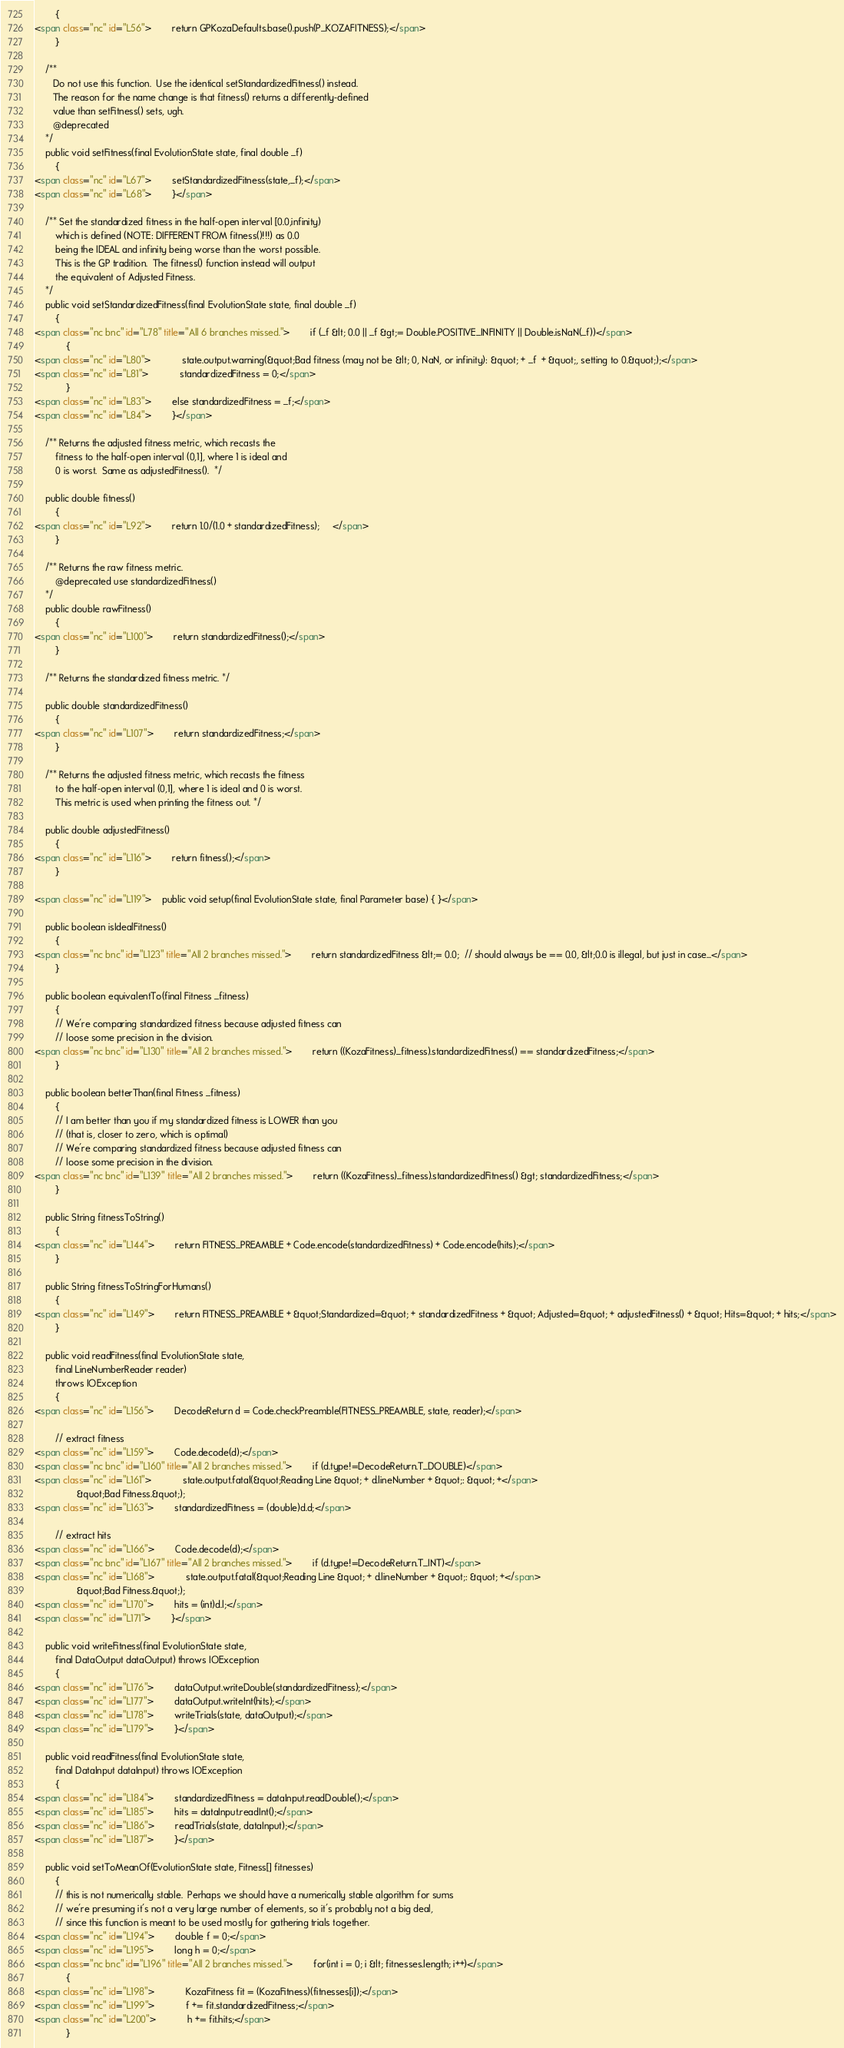<code> <loc_0><loc_0><loc_500><loc_500><_HTML_>        {
<span class="nc" id="L56">        return GPKozaDefaults.base().push(P_KOZAFITNESS);</span>
        }
        
    /**
       Do not use this function.  Use the identical setStandardizedFitness() instead.
       The reason for the name change is that fitness() returns a differently-defined
       value than setFitness() sets, ugh.
       @deprecated
    */
    public void setFitness(final EvolutionState state, final double _f)
        {
<span class="nc" id="L67">        setStandardizedFitness(state,_f);</span>
<span class="nc" id="L68">        }</span>

    /** Set the standardized fitness in the half-open interval [0.0,infinity)
        which is defined (NOTE: DIFFERENT FROM fitness()!!!) as 0.0 
        being the IDEAL and infinity being worse than the worst possible.
        This is the GP tradition.  The fitness() function instead will output
        the equivalent of Adjusted Fitness.
    */
    public void setStandardizedFitness(final EvolutionState state, final double _f)
        {
<span class="nc bnc" id="L78" title="All 6 branches missed.">        if (_f &lt; 0.0 || _f &gt;= Double.POSITIVE_INFINITY || Double.isNaN(_f))</span>
            {
<span class="nc" id="L80">            state.output.warning(&quot;Bad fitness (may not be &lt; 0, NaN, or infinity): &quot; + _f  + &quot;, setting to 0.&quot;);</span>
<span class="nc" id="L81">            standardizedFitness = 0;</span>
            }
<span class="nc" id="L83">        else standardizedFitness = _f;</span>
<span class="nc" id="L84">        }</span>

    /** Returns the adjusted fitness metric, which recasts the
        fitness to the half-open interval (0,1], where 1 is ideal and
        0 is worst.  Same as adjustedFitness().  */

    public double fitness()
        {
<span class="nc" id="L92">        return 1.0/(1.0 + standardizedFitness);     </span>
        }

    /** Returns the raw fitness metric.  
        @deprecated use standardizedFitness()
    */
    public double rawFitness()
        {
<span class="nc" id="L100">        return standardizedFitness();</span>
        }

    /** Returns the standardized fitness metric. */

    public double standardizedFitness()
        {
<span class="nc" id="L107">        return standardizedFitness;</span>
        }

    /** Returns the adjusted fitness metric, which recasts the fitness
        to the half-open interval (0,1], where 1 is ideal and 0 is worst.
        This metric is used when printing the fitness out. */

    public double adjustedFitness()
        {
<span class="nc" id="L116">        return fitness();</span>
        }

<span class="nc" id="L119">    public void setup(final EvolutionState state, final Parameter base) { }</span>
    
    public boolean isIdealFitness()
        {
<span class="nc bnc" id="L123" title="All 2 branches missed.">        return standardizedFitness &lt;= 0.0;  // should always be == 0.0, &lt;0.0 is illegal, but just in case...</span>
        }
    
    public boolean equivalentTo(final Fitness _fitness)
        {
        // We're comparing standardized fitness because adjusted fitness can
        // loose some precision in the division.
<span class="nc bnc" id="L130" title="All 2 branches missed.">        return ((KozaFitness)_fitness).standardizedFitness() == standardizedFitness;</span>
        }

    public boolean betterThan(final Fitness _fitness)
        {
        // I am better than you if my standardized fitness is LOWER than you
        // (that is, closer to zero, which is optimal)
        // We're comparing standardized fitness because adjusted fitness can
        // loose some precision in the division.
<span class="nc bnc" id="L139" title="All 2 branches missed.">        return ((KozaFitness)_fitness).standardizedFitness() &gt; standardizedFitness;</span>
        }
 
    public String fitnessToString()
        {
<span class="nc" id="L144">        return FITNESS_PREAMBLE + Code.encode(standardizedFitness) + Code.encode(hits);</span>
        }
        
    public String fitnessToStringForHumans()
        {
<span class="nc" id="L149">        return FITNESS_PREAMBLE + &quot;Standardized=&quot; + standardizedFitness + &quot; Adjusted=&quot; + adjustedFitness() + &quot; Hits=&quot; + hits;</span>
        }
            
    public void readFitness(final EvolutionState state, 
        final LineNumberReader reader)
        throws IOException
        {
<span class="nc" id="L156">        DecodeReturn d = Code.checkPreamble(FITNESS_PREAMBLE, state, reader);</span>
        
        // extract fitness
<span class="nc" id="L159">        Code.decode(d);</span>
<span class="nc bnc" id="L160" title="All 2 branches missed.">        if (d.type!=DecodeReturn.T_DOUBLE)</span>
<span class="nc" id="L161">            state.output.fatal(&quot;Reading Line &quot; + d.lineNumber + &quot;: &quot; +</span>
                &quot;Bad Fitness.&quot;);
<span class="nc" id="L163">        standardizedFitness = (double)d.d;</span>
        
        // extract hits
<span class="nc" id="L166">        Code.decode(d);</span>
<span class="nc bnc" id="L167" title="All 2 branches missed.">        if (d.type!=DecodeReturn.T_INT)</span>
<span class="nc" id="L168">            state.output.fatal(&quot;Reading Line &quot; + d.lineNumber + &quot;: &quot; +</span>
                &quot;Bad Fitness.&quot;);
<span class="nc" id="L170">        hits = (int)d.l;</span>
<span class="nc" id="L171">        }</span>

    public void writeFitness(final EvolutionState state,
        final DataOutput dataOutput) throws IOException
        {
<span class="nc" id="L176">        dataOutput.writeDouble(standardizedFitness);</span>
<span class="nc" id="L177">        dataOutput.writeInt(hits);</span>
<span class="nc" id="L178">        writeTrials(state, dataOutput);</span>
<span class="nc" id="L179">        }</span>

    public void readFitness(final EvolutionState state,
        final DataInput dataInput) throws IOException
        {
<span class="nc" id="L184">        standardizedFitness = dataInput.readDouble();</span>
<span class="nc" id="L185">        hits = dataInput.readInt();</span>
<span class="nc" id="L186">        readTrials(state, dataInput);</span>
<span class="nc" id="L187">        }</span>

    public void setToMeanOf(EvolutionState state, Fitness[] fitnesses)
        {
        // this is not numerically stable.  Perhaps we should have a numerically stable algorithm for sums
        // we're presuming it's not a very large number of elements, so it's probably not a big deal,
        // since this function is meant to be used mostly for gathering trials together.
<span class="nc" id="L194">        double f = 0;</span>
<span class="nc" id="L195">        long h = 0;</span>
<span class="nc bnc" id="L196" title="All 2 branches missed.">        for(int i = 0; i &lt; fitnesses.length; i++)</span>
            {
<span class="nc" id="L198">            KozaFitness fit = (KozaFitness)(fitnesses[i]);</span>
<span class="nc" id="L199">            f += fit.standardizedFitness;</span>
<span class="nc" id="L200">            h += fit.hits;</span>
            }</code> 